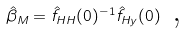<formula> <loc_0><loc_0><loc_500><loc_500>\hat { \beta } _ { M } = \hat { f } _ { H H } ( 0 ) ^ { - 1 } \hat { f } _ { H y } ( 0 ) \text { ,}</formula> 